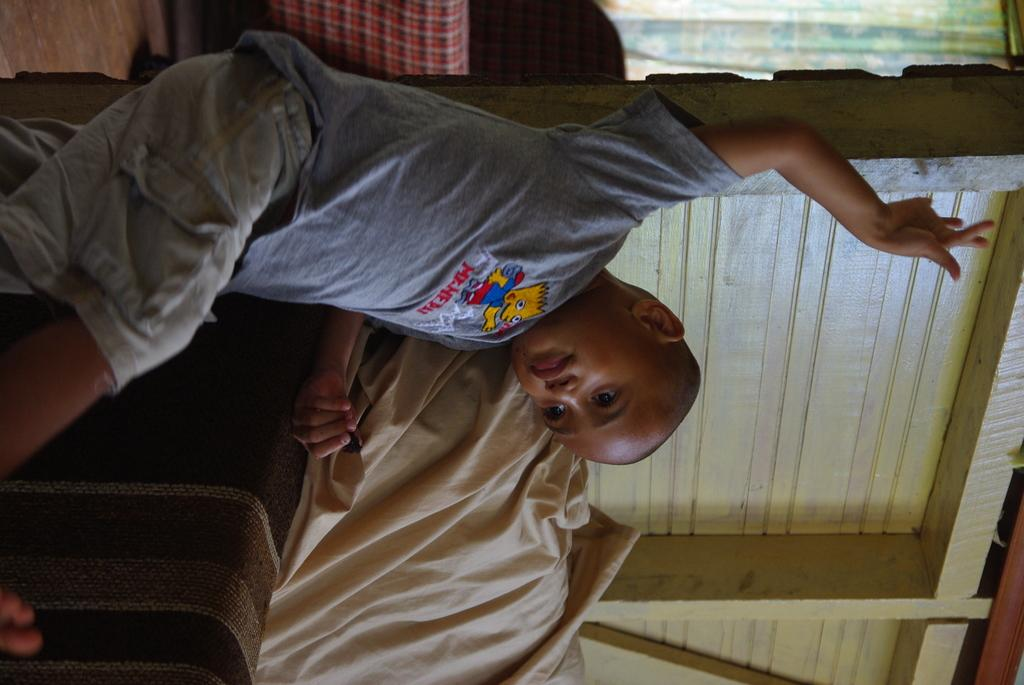Who is in the image? There is a boy in the image. What is the boy wearing? The boy is wearing a gray T-shirt. What is the boy doing in the image? The boy is leaning on a sofa. What is on the sofa? There is a cloth on the sofa. What can be seen in the background of the image? There is a wooden wall, a curtain, and other objects in the background. How many pears are on the stick in the image? There are no pears or sticks present in the image. 